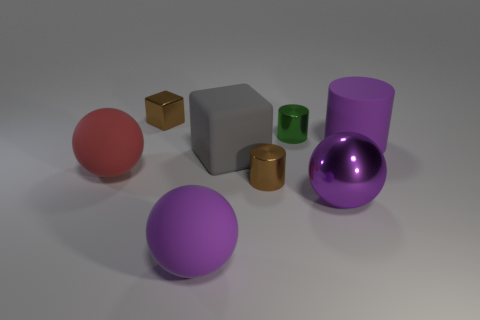Subtract all yellow blocks. How many purple balls are left? 2 Subtract all purple balls. How many balls are left? 1 Add 1 large green metallic cylinders. How many objects exist? 9 Subtract 1 blocks. How many blocks are left? 1 Subtract all spheres. How many objects are left? 5 Subtract all yellow matte things. Subtract all large gray rubber blocks. How many objects are left? 7 Add 4 large purple metallic spheres. How many large purple metallic spheres are left? 5 Add 2 small brown metallic things. How many small brown metallic things exist? 4 Subtract 1 brown cylinders. How many objects are left? 7 Subtract all red cylinders. Subtract all cyan balls. How many cylinders are left? 3 